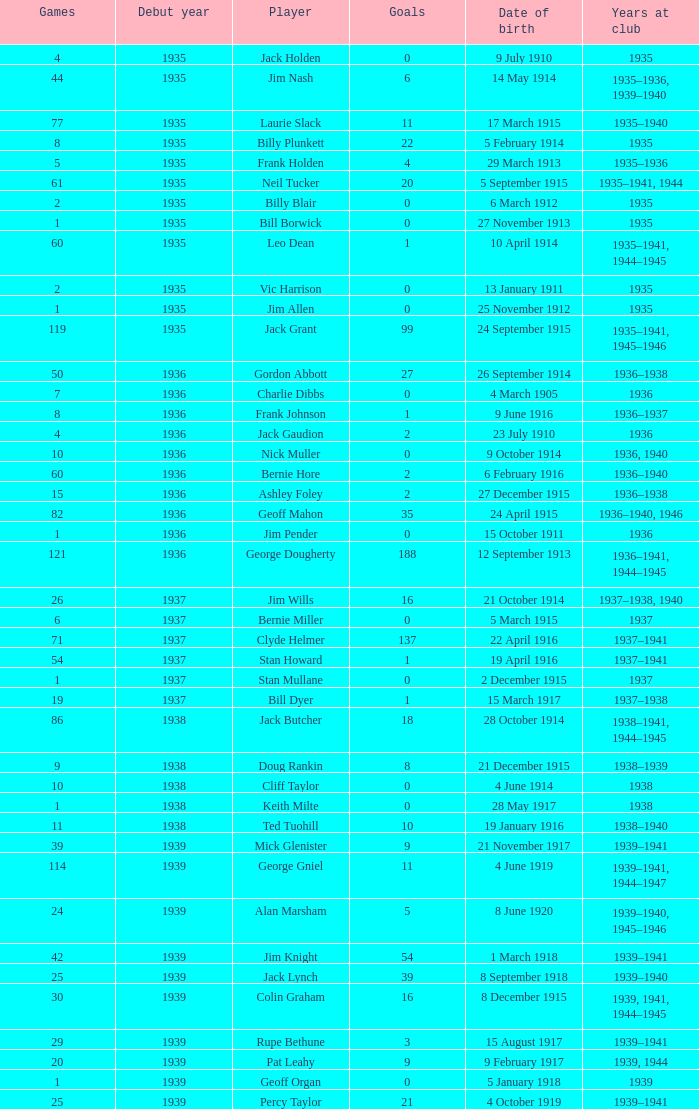What is the lowest number of games Jack Gaudion, who debut in 1936, played? 4.0. 